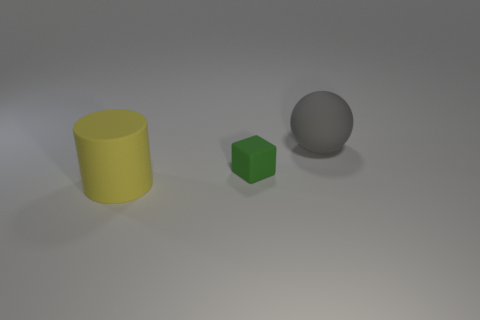What is the shape of the object that is the same size as the cylinder?
Provide a succinct answer. Sphere. The thing that is the same size as the matte cylinder is what color?
Offer a terse response. Gray. Is the size of the rubber sphere the same as the yellow object?
Ensure brevity in your answer.  Yes. There is a matte thing that is both in front of the big gray matte sphere and behind the matte cylinder; how big is it?
Your answer should be very brief. Small. What number of rubber objects are yellow cylinders or small cyan balls?
Ensure brevity in your answer.  1. Is the number of matte things that are in front of the gray rubber object greater than the number of big green rubber cubes?
Give a very brief answer. Yes. What is the big thing that is behind the yellow object made of?
Keep it short and to the point. Rubber. How many big gray things are made of the same material as the block?
Give a very brief answer. 1. What shape is the matte object that is behind the yellow cylinder and on the left side of the gray matte sphere?
Ensure brevity in your answer.  Cube. What number of things are rubber objects to the left of the big sphere or rubber objects on the right side of the yellow rubber cylinder?
Make the answer very short. 3. 